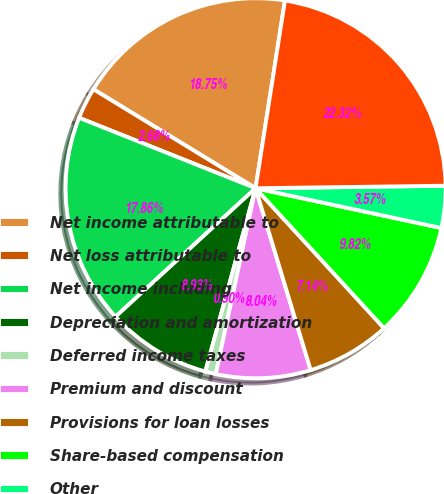Convert chart. <chart><loc_0><loc_0><loc_500><loc_500><pie_chart><fcel>Net income attributable to<fcel>Net loss attributable to<fcel>Net income including<fcel>Depreciation and amortization<fcel>Deferred income taxes<fcel>Premium and discount<fcel>Provisions for loan losses<fcel>Share-based compensation<fcel>Other<fcel>Assets segregated pursuant to<nl><fcel>18.75%<fcel>2.68%<fcel>17.86%<fcel>8.93%<fcel>0.9%<fcel>8.04%<fcel>7.14%<fcel>9.82%<fcel>3.57%<fcel>22.32%<nl></chart> 